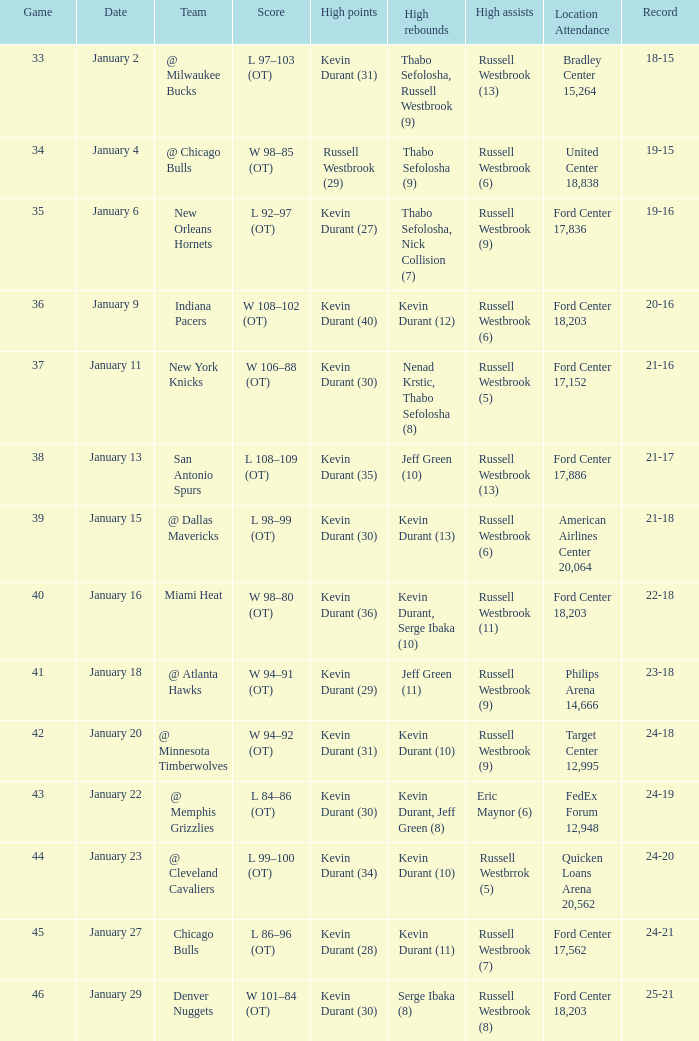Name the location attendance for january 18 Philips Arena 14,666. 